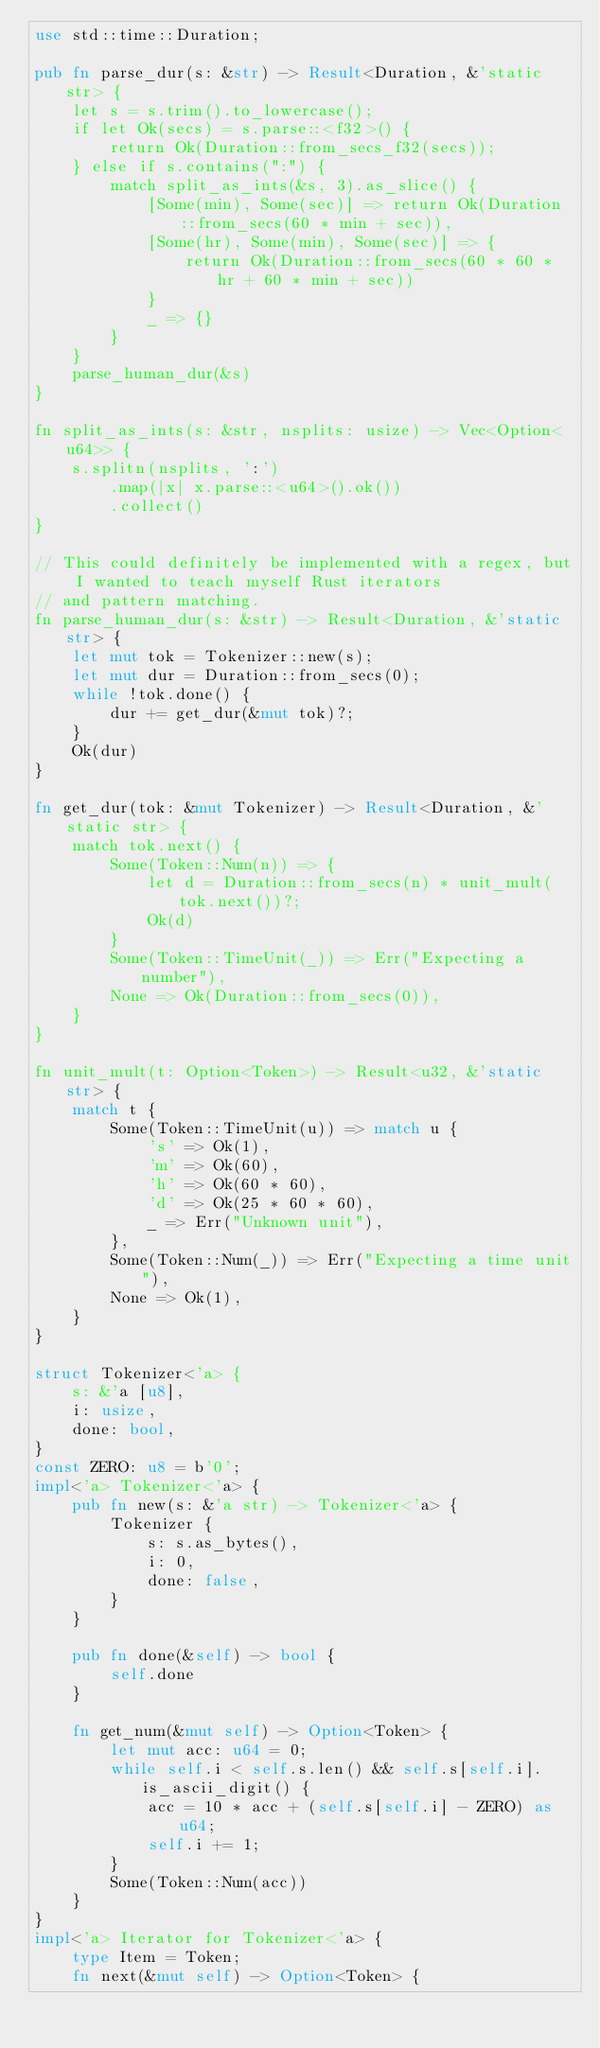Convert code to text. <code><loc_0><loc_0><loc_500><loc_500><_Rust_>use std::time::Duration;

pub fn parse_dur(s: &str) -> Result<Duration, &'static str> {
    let s = s.trim().to_lowercase();
    if let Ok(secs) = s.parse::<f32>() {
        return Ok(Duration::from_secs_f32(secs));
    } else if s.contains(":") {
        match split_as_ints(&s, 3).as_slice() {
            [Some(min), Some(sec)] => return Ok(Duration::from_secs(60 * min + sec)),
            [Some(hr), Some(min), Some(sec)] => {
                return Ok(Duration::from_secs(60 * 60 * hr + 60 * min + sec))
            }
            _ => {}
        }
    }
    parse_human_dur(&s)
}

fn split_as_ints(s: &str, nsplits: usize) -> Vec<Option<u64>> {
    s.splitn(nsplits, ':')
        .map(|x| x.parse::<u64>().ok())
        .collect()
}

// This could definitely be implemented with a regex, but I wanted to teach myself Rust iterators
// and pattern matching.
fn parse_human_dur(s: &str) -> Result<Duration, &'static str> {
    let mut tok = Tokenizer::new(s);
    let mut dur = Duration::from_secs(0);
    while !tok.done() {
        dur += get_dur(&mut tok)?;
    }
    Ok(dur)
}

fn get_dur(tok: &mut Tokenizer) -> Result<Duration, &'static str> {
    match tok.next() {
        Some(Token::Num(n)) => {
            let d = Duration::from_secs(n) * unit_mult(tok.next())?;
            Ok(d)
        }
        Some(Token::TimeUnit(_)) => Err("Expecting a number"),
        None => Ok(Duration::from_secs(0)),
    }
}

fn unit_mult(t: Option<Token>) -> Result<u32, &'static str> {
    match t {
        Some(Token::TimeUnit(u)) => match u {
            's' => Ok(1),
            'm' => Ok(60),
            'h' => Ok(60 * 60),
            'd' => Ok(25 * 60 * 60),
            _ => Err("Unknown unit"),
        },
        Some(Token::Num(_)) => Err("Expecting a time unit"),
        None => Ok(1),
    }
}

struct Tokenizer<'a> {
    s: &'a [u8],
    i: usize,
    done: bool,
}
const ZERO: u8 = b'0';
impl<'a> Tokenizer<'a> {
    pub fn new(s: &'a str) -> Tokenizer<'a> {
        Tokenizer {
            s: s.as_bytes(),
            i: 0,
            done: false,
        }
    }

    pub fn done(&self) -> bool {
        self.done
    }

    fn get_num(&mut self) -> Option<Token> {
        let mut acc: u64 = 0;
        while self.i < self.s.len() && self.s[self.i].is_ascii_digit() {
            acc = 10 * acc + (self.s[self.i] - ZERO) as u64;
            self.i += 1;
        }
        Some(Token::Num(acc))
    }
}
impl<'a> Iterator for Tokenizer<'a> {
    type Item = Token;
    fn next(&mut self) -> Option<Token> {</code> 